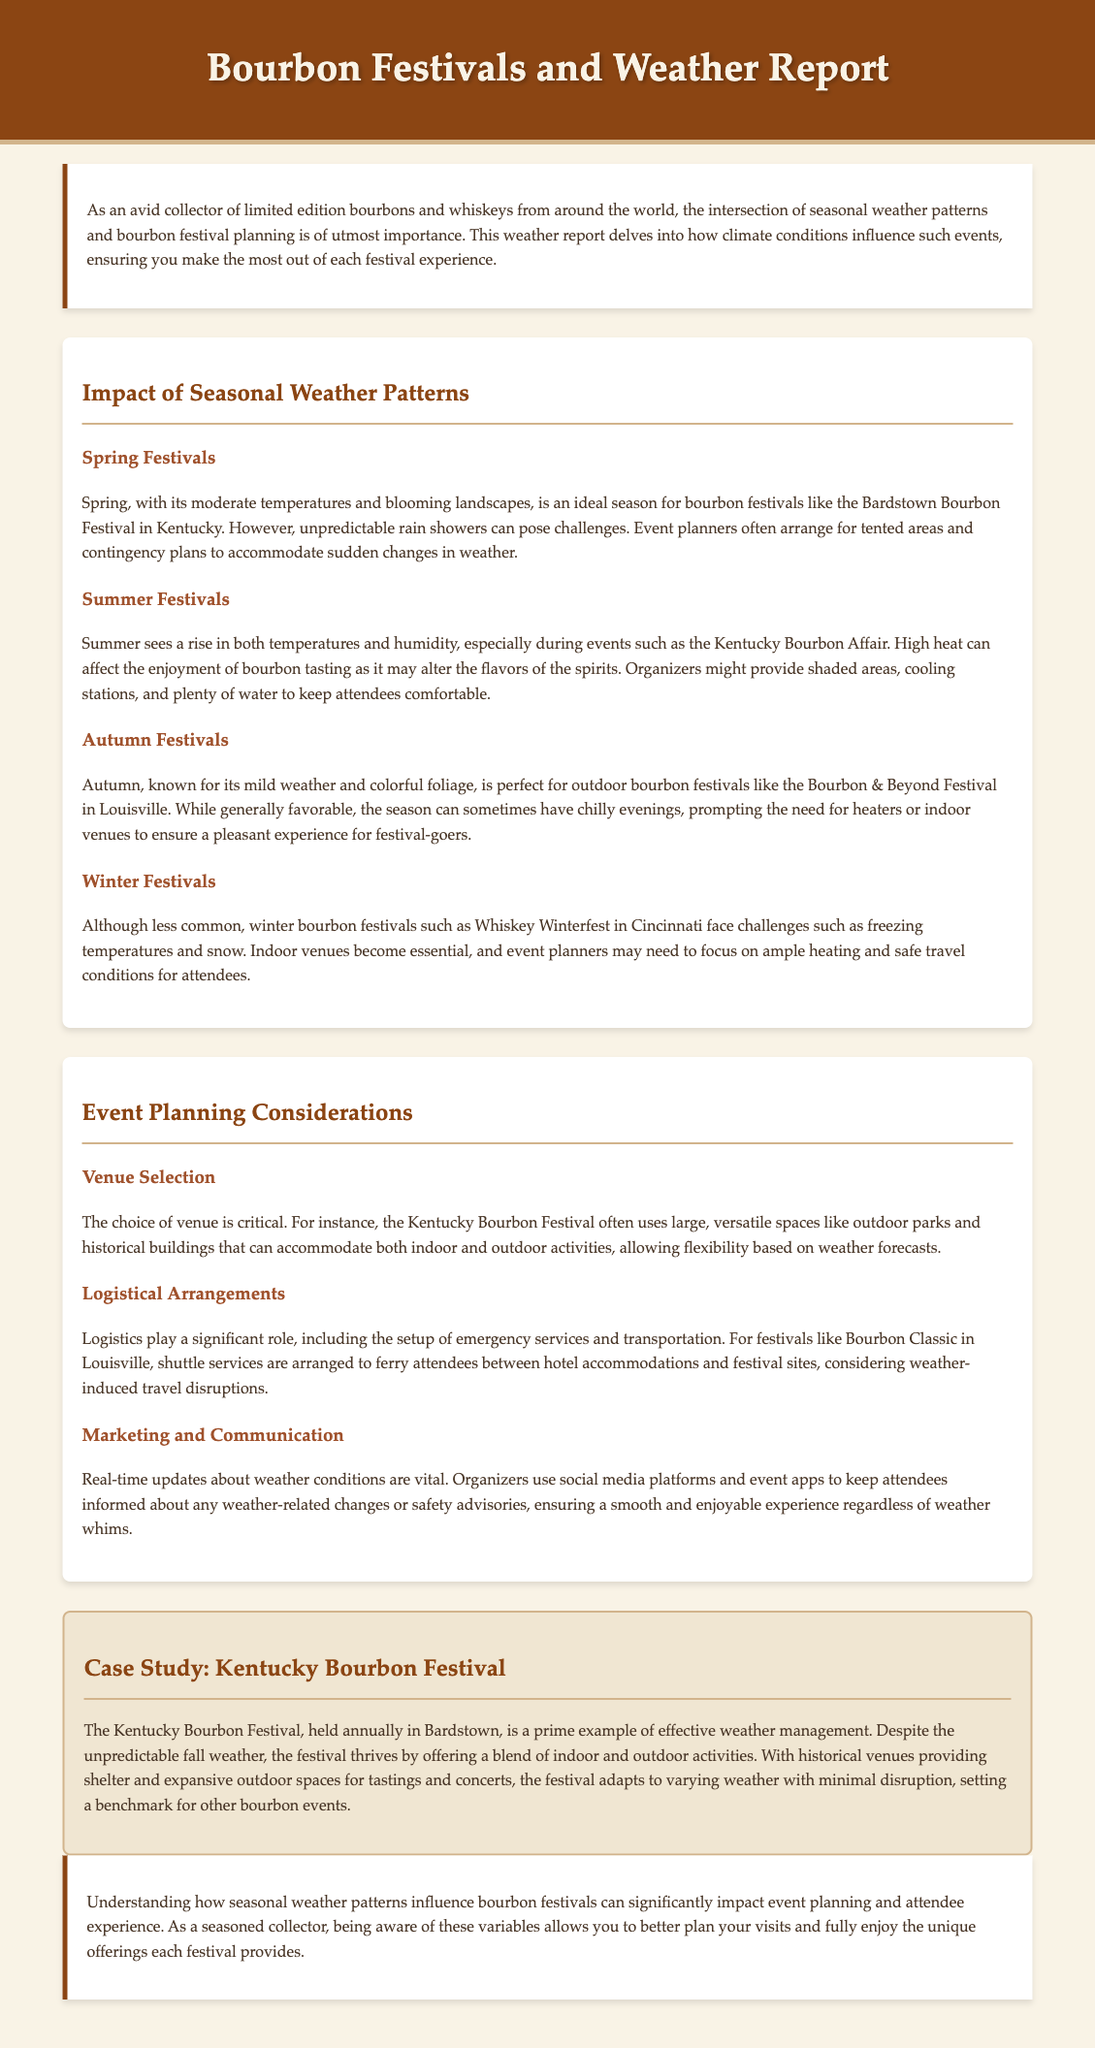What is the ideal season for bourbon festivals in Kentucky? The document states that spring is an ideal season for bourbon festivals in Kentucky due to moderate temperatures and blooming landscapes.
Answer: Spring What is a major challenge for spring festivals? The document mentions unpredictable rain showers as a significant challenge for spring festival planning.
Answer: Unpredictable rain showers What outdoor festival takes place in autumn? The Bourbon & Beyond Festival is specifically mentioned as an outdoor bourbon festival held in autumn.
Answer: Bourbon & Beyond Festival Which festival is held during winter? The document refers to Whiskey Winterfest in Cincinnati as a winter bourbon festival.
Answer: Whiskey Winterfest What kind of arrangements do summer festival organizers make? Organizers of summer festivals provide shaded areas and cooling stations to keep attendees comfortable during high heat.
Answer: Shaded areas and cooling stations What factor is vital for real-time updates about weather conditions? The document highlights that organizers use social media platforms and event apps for real-time updates regarding weather conditions, emphasizing the importance of communication in event planning.
Answer: Social media platforms and event apps How does the Kentucky Bourbon Festival manage weather unpredictability? The festival utilizes a blend of indoor and outdoor activities, allowing for adaptation to varying weather conditions with minimal disruption.
Answer: Blend of indoor and outdoor activities What venues are typically used for the Kentucky Bourbon Festival? Large outdoor parks and historical buildings are mentioned as the typical venues for the Kentucky Bourbon Festival.
Answer: Large outdoor parks and historical buildings What is cited as a common feature of autumn festivals? The document states that autumn festivals are known for their mild weather and colorful foliage, which are generally favorable for event planning.
Answer: Mild weather and colorful foliage 